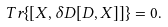Convert formula to latex. <formula><loc_0><loc_0><loc_500><loc_500>T r \{ [ X , \delta D [ D , X ] ] \} = 0 .</formula> 